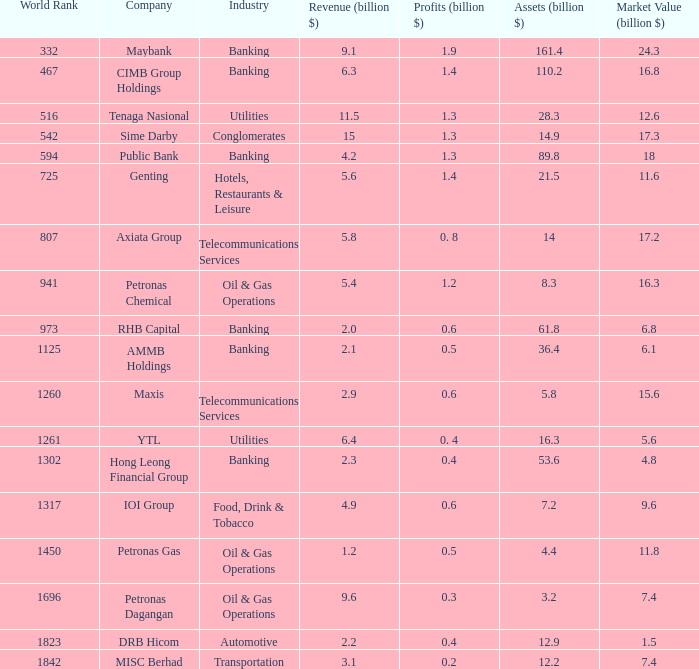1 income. Banking. 